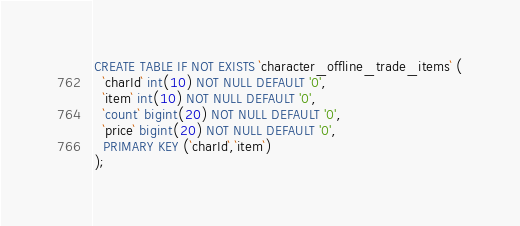Convert code to text. <code><loc_0><loc_0><loc_500><loc_500><_SQL_>CREATE TABLE IF NOT EXISTS `character_offline_trade_items` (
  `charId` int(10) NOT NULL DEFAULT '0',
  `item` int(10) NOT NULL DEFAULT '0',
  `count` bigint(20) NOT NULL DEFAULT '0',
  `price` bigint(20) NOT NULL DEFAULT '0',
  PRIMARY KEY (`charId`,`item`)
);</code> 